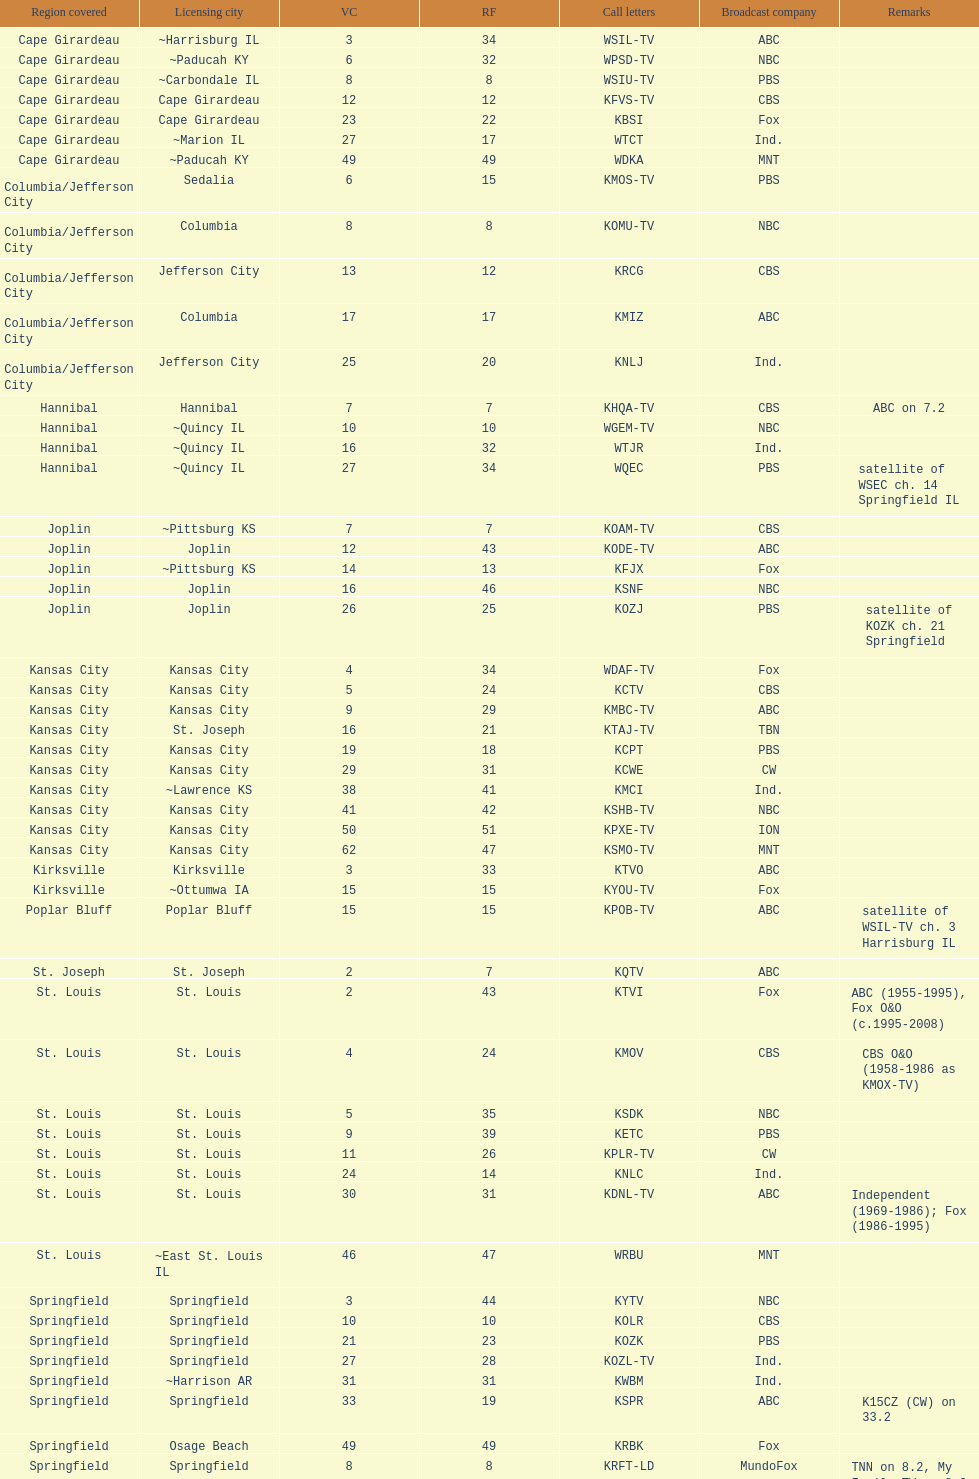Parse the full table. {'header': ['Region covered', 'Licensing city', 'VC', 'RF', 'Call letters', 'Broadcast company', 'Remarks'], 'rows': [['Cape Girardeau', '~Harrisburg IL', '3', '34', 'WSIL-TV', 'ABC', ''], ['Cape Girardeau', '~Paducah KY', '6', '32', 'WPSD-TV', 'NBC', ''], ['Cape Girardeau', '~Carbondale IL', '8', '8', 'WSIU-TV', 'PBS', ''], ['Cape Girardeau', 'Cape Girardeau', '12', '12', 'KFVS-TV', 'CBS', ''], ['Cape Girardeau', 'Cape Girardeau', '23', '22', 'KBSI', 'Fox', ''], ['Cape Girardeau', '~Marion IL', '27', '17', 'WTCT', 'Ind.', ''], ['Cape Girardeau', '~Paducah KY', '49', '49', 'WDKA', 'MNT', ''], ['Columbia/Jefferson City', 'Sedalia', '6', '15', 'KMOS-TV', 'PBS', ''], ['Columbia/Jefferson City', 'Columbia', '8', '8', 'KOMU-TV', 'NBC', ''], ['Columbia/Jefferson City', 'Jefferson City', '13', '12', 'KRCG', 'CBS', ''], ['Columbia/Jefferson City', 'Columbia', '17', '17', 'KMIZ', 'ABC', ''], ['Columbia/Jefferson City', 'Jefferson City', '25', '20', 'KNLJ', 'Ind.', ''], ['Hannibal', 'Hannibal', '7', '7', 'KHQA-TV', 'CBS', 'ABC on 7.2'], ['Hannibal', '~Quincy IL', '10', '10', 'WGEM-TV', 'NBC', ''], ['Hannibal', '~Quincy IL', '16', '32', 'WTJR', 'Ind.', ''], ['Hannibal', '~Quincy IL', '27', '34', 'WQEC', 'PBS', 'satellite of WSEC ch. 14 Springfield IL'], ['Joplin', '~Pittsburg KS', '7', '7', 'KOAM-TV', 'CBS', ''], ['Joplin', 'Joplin', '12', '43', 'KODE-TV', 'ABC', ''], ['Joplin', '~Pittsburg KS', '14', '13', 'KFJX', 'Fox', ''], ['Joplin', 'Joplin', '16', '46', 'KSNF', 'NBC', ''], ['Joplin', 'Joplin', '26', '25', 'KOZJ', 'PBS', 'satellite of KOZK ch. 21 Springfield'], ['Kansas City', 'Kansas City', '4', '34', 'WDAF-TV', 'Fox', ''], ['Kansas City', 'Kansas City', '5', '24', 'KCTV', 'CBS', ''], ['Kansas City', 'Kansas City', '9', '29', 'KMBC-TV', 'ABC', ''], ['Kansas City', 'St. Joseph', '16', '21', 'KTAJ-TV', 'TBN', ''], ['Kansas City', 'Kansas City', '19', '18', 'KCPT', 'PBS', ''], ['Kansas City', 'Kansas City', '29', '31', 'KCWE', 'CW', ''], ['Kansas City', '~Lawrence KS', '38', '41', 'KMCI', 'Ind.', ''], ['Kansas City', 'Kansas City', '41', '42', 'KSHB-TV', 'NBC', ''], ['Kansas City', 'Kansas City', '50', '51', 'KPXE-TV', 'ION', ''], ['Kansas City', 'Kansas City', '62', '47', 'KSMO-TV', 'MNT', ''], ['Kirksville', 'Kirksville', '3', '33', 'KTVO', 'ABC', ''], ['Kirksville', '~Ottumwa IA', '15', '15', 'KYOU-TV', 'Fox', ''], ['Poplar Bluff', 'Poplar Bluff', '15', '15', 'KPOB-TV', 'ABC', 'satellite of WSIL-TV ch. 3 Harrisburg IL'], ['St. Joseph', 'St. Joseph', '2', '7', 'KQTV', 'ABC', ''], ['St. Louis', 'St. Louis', '2', '43', 'KTVI', 'Fox', 'ABC (1955-1995), Fox O&O (c.1995-2008)'], ['St. Louis', 'St. Louis', '4', '24', 'KMOV', 'CBS', 'CBS O&O (1958-1986 as KMOX-TV)'], ['St. Louis', 'St. Louis', '5', '35', 'KSDK', 'NBC', ''], ['St. Louis', 'St. Louis', '9', '39', 'KETC', 'PBS', ''], ['St. Louis', 'St. Louis', '11', '26', 'KPLR-TV', 'CW', ''], ['St. Louis', 'St. Louis', '24', '14', 'KNLC', 'Ind.', ''], ['St. Louis', 'St. Louis', '30', '31', 'KDNL-TV', 'ABC', 'Independent (1969-1986); Fox (1986-1995)'], ['St. Louis', '~East St. Louis IL', '46', '47', 'WRBU', 'MNT', ''], ['Springfield', 'Springfield', '3', '44', 'KYTV', 'NBC', ''], ['Springfield', 'Springfield', '10', '10', 'KOLR', 'CBS', ''], ['Springfield', 'Springfield', '21', '23', 'KOZK', 'PBS', ''], ['Springfield', 'Springfield', '27', '28', 'KOZL-TV', 'Ind.', ''], ['Springfield', '~Harrison AR', '31', '31', 'KWBM', 'Ind.', ''], ['Springfield', 'Springfield', '33', '19', 'KSPR', 'ABC', 'K15CZ (CW) on 33.2'], ['Springfield', 'Osage Beach', '49', '49', 'KRBK', 'Fox', ''], ['Springfield', 'Springfield', '8', '8', 'KRFT-LD', 'MundoFox', 'TNN on 8.2, My Family TV on 8.3']]} What is the total number of stations serving the the cape girardeau area? 7. 